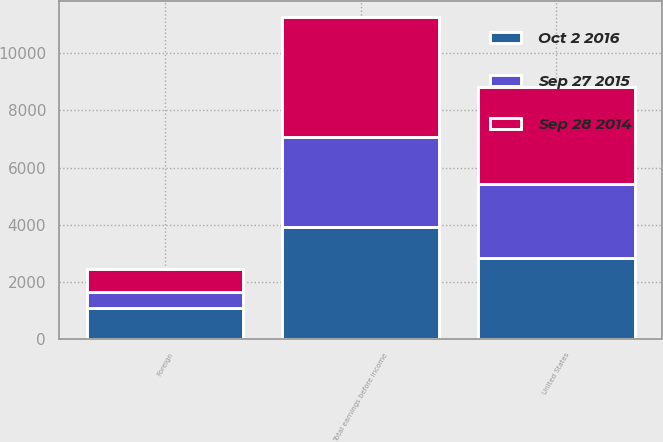Convert chart. <chart><loc_0><loc_0><loc_500><loc_500><stacked_bar_chart><ecel><fcel>United States<fcel>Foreign<fcel>Total earnings before income<nl><fcel>Sep 28 2014<fcel>3415.7<fcel>782.9<fcel>4198.6<nl><fcel>Oct 2 2016<fcel>2837.2<fcel>1065.8<fcel>3903<nl><fcel>Sep 27 2015<fcel>2572.4<fcel>587.3<fcel>3159.7<nl></chart> 